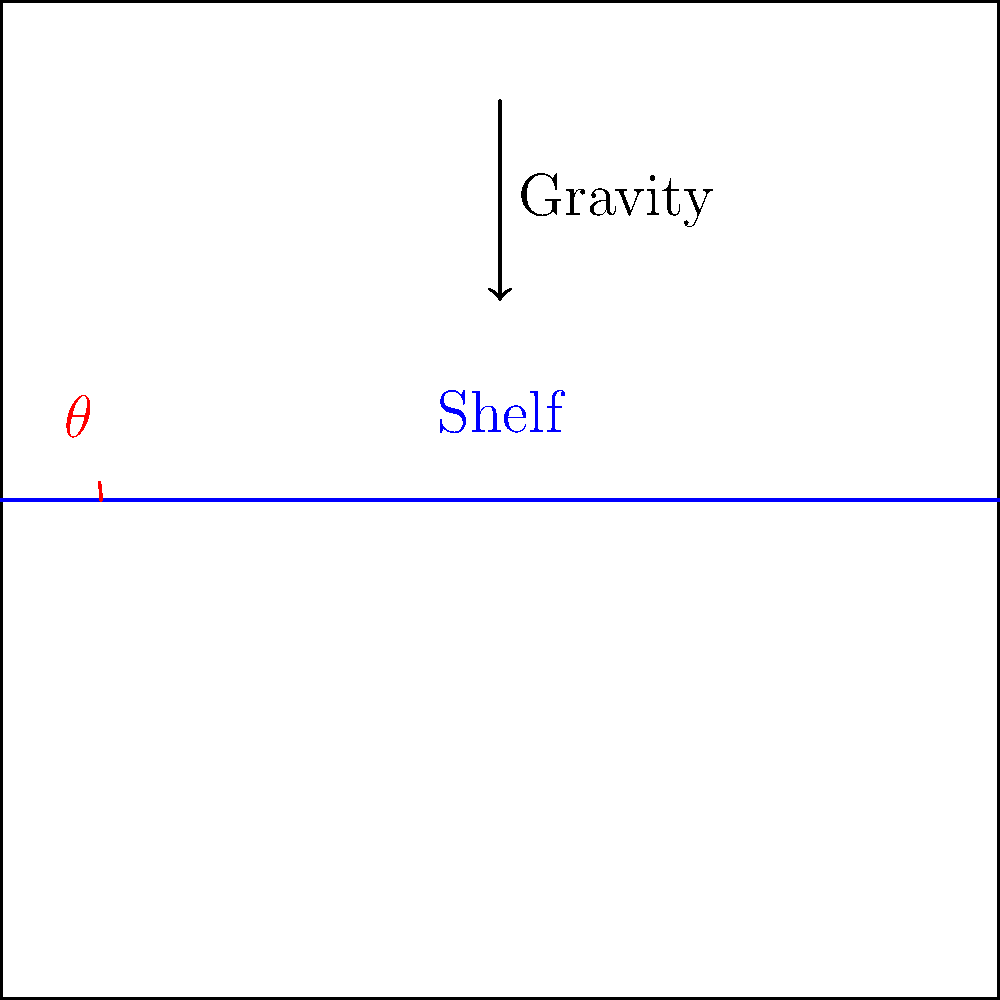What is the ideal angle $\theta$ for refrigerator shelves to prevent cross-contamination and spills in a commercial kitchen setting? To determine the ideal angle for refrigerator shelves, we need to consider several factors:

1. Gravity: The main force acting on items on the shelf.
2. Friction: Prevents items from sliding too easily.
3. Visibility: Allows for easy inspection of items.
4. Accessibility: Ensures items can be reached without difficulty.

Step 1: Consider the effect of gravity.
A completely flat shelf ($\theta = 0°$) would allow liquids to pool and potentially spread.

Step 2: Evaluate the need for slight inclination.
A small angle helps liquids flow towards the back of the shelf, containing potential spills.

Step 3: Balance inclination with stability.
Too steep an angle would cause items to slide off easily.

Step 4: Account for industry standards and research.
Food safety experts and refrigerator manufacturers typically recommend a slight backwards tilt.

Step 5: Determine the optimal angle.
The ideal angle is generally accepted to be between 5° and 10°. This range:
- Allows for proper drainage
- Prevents items from sliding off
- Maintains visibility and accessibility

Step 6: Specify the most commonly recommended angle.
Within this range, 5° is often cited as the optimal angle, balancing all factors effectively.
Answer: 5° 